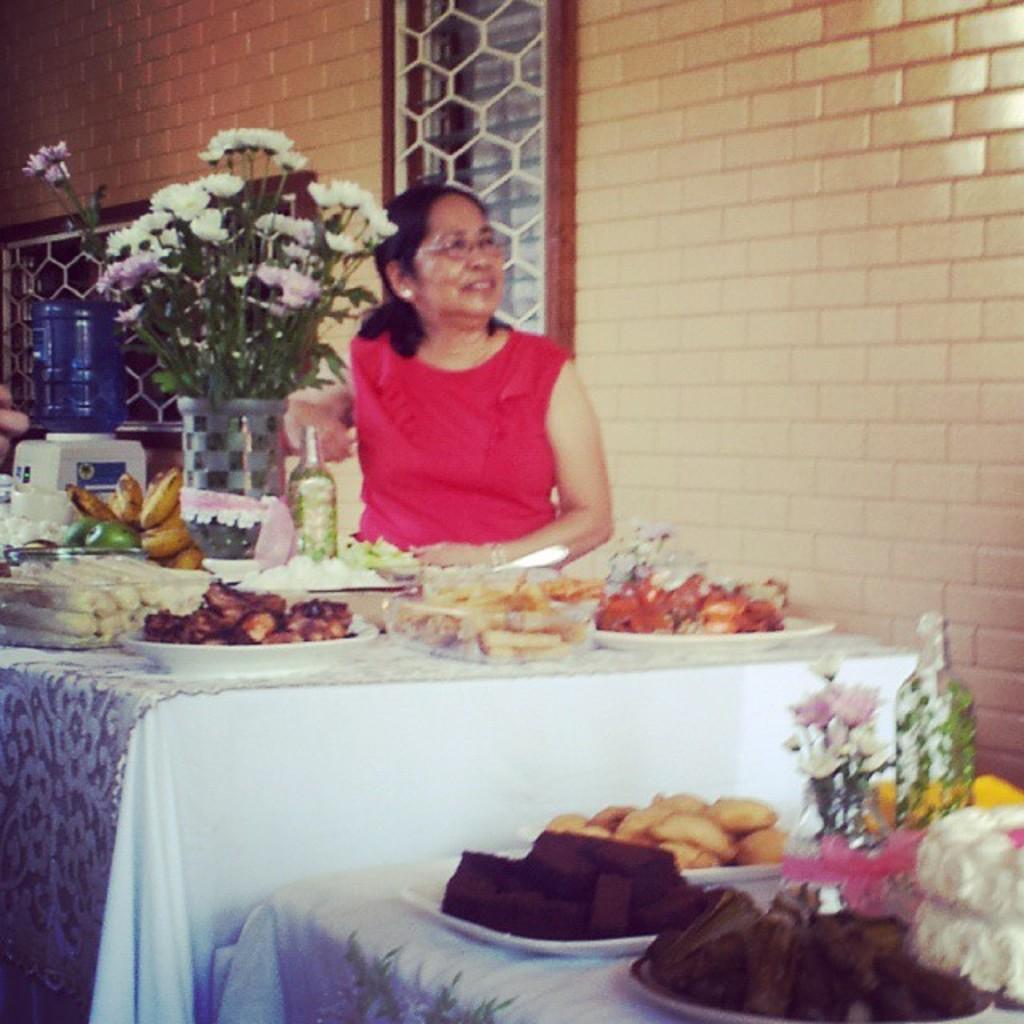Please provide a concise description of this image. In this image, women in red color is near to the white color table. there are so many items are placed on it. Here we can see flower vase, flower, can. And here right side, cream color tile wall, wooden window and glass here. 